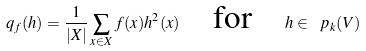Convert formula to latex. <formula><loc_0><loc_0><loc_500><loc_500>q _ { f } ( h ) = \frac { 1 } { | X | } \sum _ { x \in X } f ( x ) h ^ { 2 } ( x ) \quad \text {for} \quad h \in \ p _ { k } ( V )</formula> 